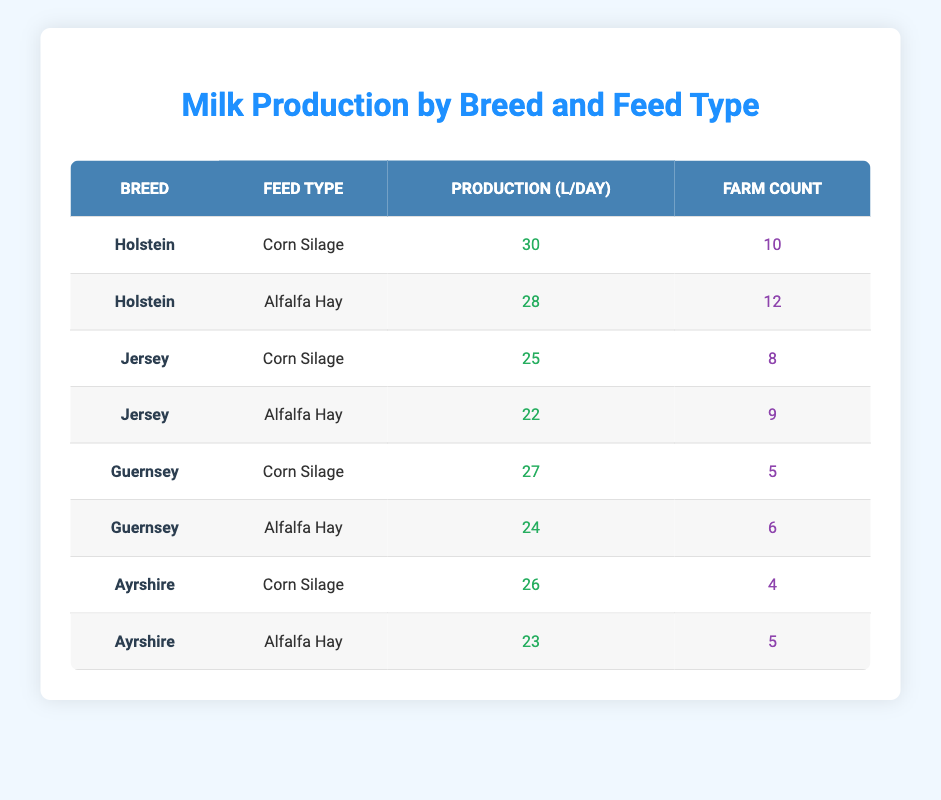What is the highest milk production per day and breed? The highest production is from the Holstein breed with Corn Silage, which is 30 liters per day.
Answer: 30 liters How many farms are producing milk from Jersey cows? There are 8 farms using Corn Silage and 9 farms using Alfalfa Hay for a total of 17 farms.
Answer: 17 farms Is the average milk production for Guernsey cows higher when fed Corn Silage or Alfalfa Hay? Guernsey cows produce 27 liters with Corn Silage and 24 liters with Alfalfa Hay. Since 27 is greater than 24, they produce more with Corn Silage.
Answer: Yes, higher with Corn Silage What is the total milk production for Ayrshire cows across both feed types? Ayrshire cows produce 26 liters with Corn Silage and 23 liters with Alfalfa Hay. Total production is 26 + 23 = 49 liters.
Answer: 49 liters How many farms utilize Alfalfa Hay for milk production? There are 12 farms with Holsteins, 9 with Jerseys, 6 with Guernseys, and 5 with Ayrshires, summing up gives 12 + 9 + 6 + 5 = 32 farms.
Answer: 32 farms Which breed has the lowest average production per day? Jersey cows produce an average of (25 + 22)/2 = 23.5 liters, which is lower than other breeds.
Answer: Jersey What is the difference in production per day between the best and worst feed type for Holstein cows? Holstein cows produce 30 liters with Corn Silage and 28 liters with Alfalfa Hay; the difference is 30 - 28 = 2 liters.
Answer: 2 liters Are there more farms feeding Corn Silage or Alfalfa Hay across all breeds? Summing the farms gives Corn Silage (10 + 8 + 5 + 4) = 27 and for Alfalfa Hay (12 + 9 + 6 + 5) = 32. Alfalfa Hay has more farms.
Answer: Alfalfa Hay has more farms What is the average milk production from all breeds for Corn Silage? The total production for Corn Silage is 30 + 25 + 27 + 26 = 108 liters for 4 breeds, giving an average of 108 / 4 = 27 liters.
Answer: 27 liters 